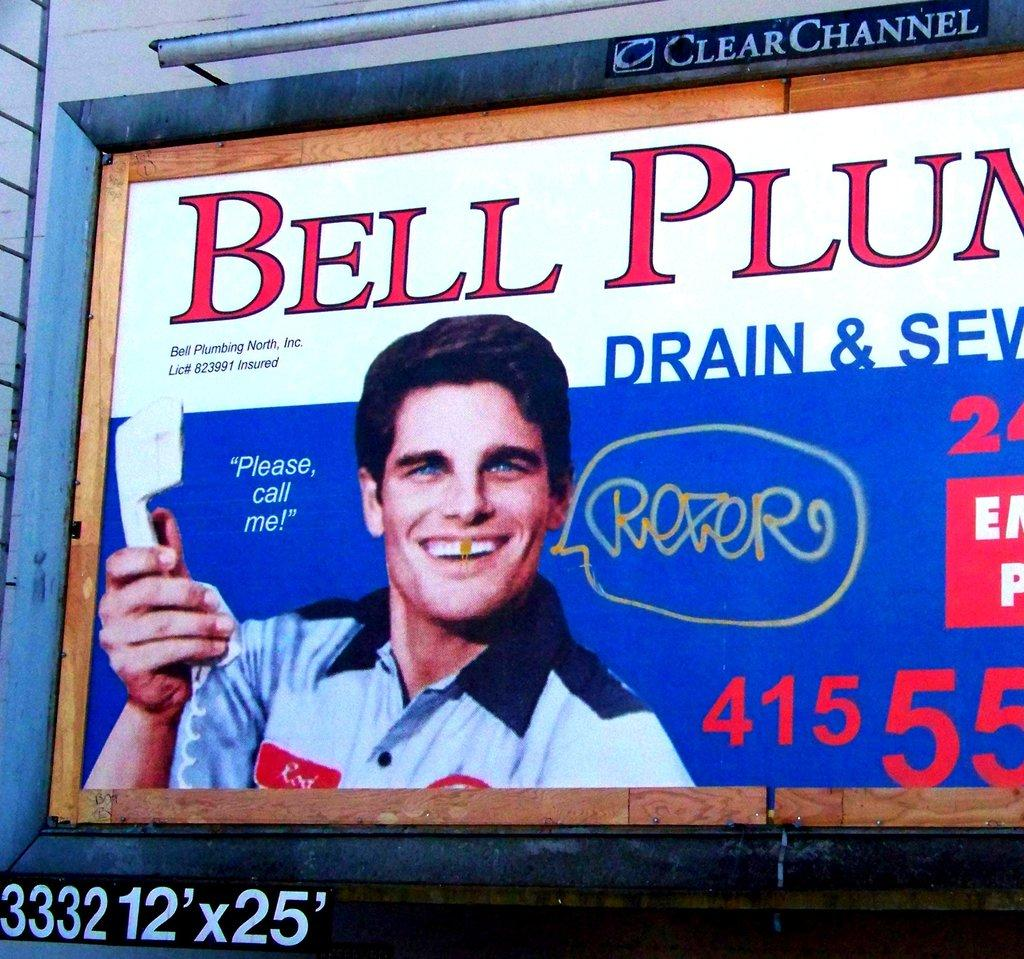<image>
Share a concise interpretation of the image provided. Billboard showing a man's face and the name BELL PLUM. 